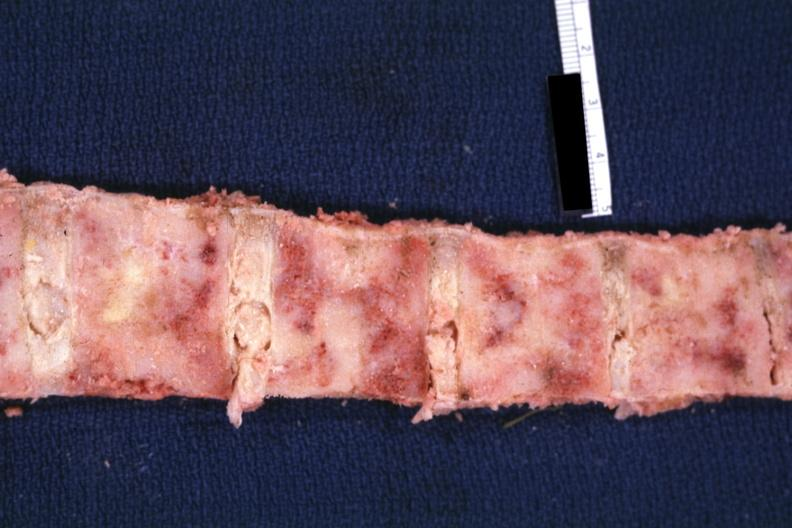s chronic ischemia lung?
Answer the question using a single word or phrase. No 